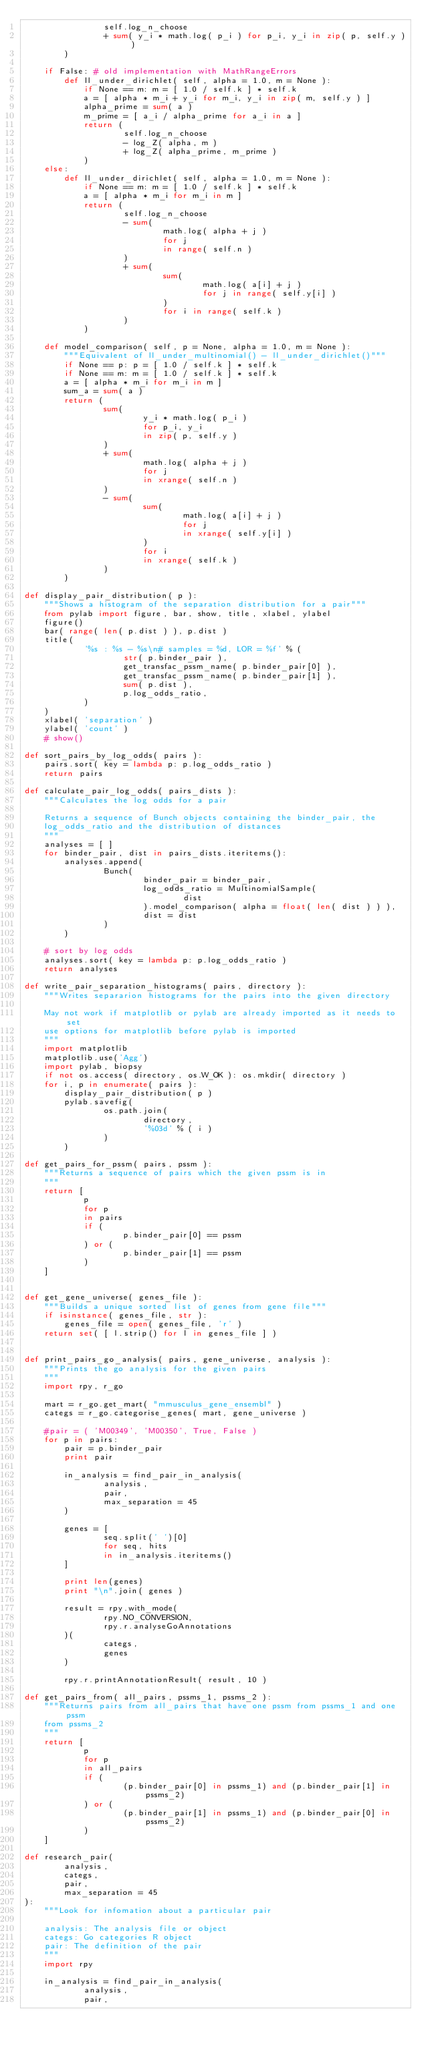Convert code to text. <code><loc_0><loc_0><loc_500><loc_500><_Python_>                self.log_n_choose
                + sum( y_i * math.log( p_i ) for p_i, y_i in zip( p, self.y ) )
        )

    if False: # old implementation with MathRangeErrors
        def ll_under_dirichlet( self, alpha = 1.0, m = None ):
            if None == m: m = [ 1.0 / self.k ] * self.k
            a = [ alpha * m_i + y_i for m_i, y_i in zip( m, self.y ) ]
            alpha_prime = sum( a )
            m_prime = [ a_i / alpha_prime for a_i in a ]
            return (
                    self.log_n_choose
                    - log_Z( alpha, m )
                    + log_Z( alpha_prime, m_prime )
            )
    else:
        def ll_under_dirichlet( self, alpha = 1.0, m = None ):
            if None == m: m = [ 1.0 / self.k ] * self.k
            a = [ alpha * m_i for m_i in m ]
            return (
                    self.log_n_choose
                    - sum(
                            math.log( alpha + j )
                            for j
                            in range( self.n )
                    )
                    + sum(
                            sum(
                                    math.log( a[i] + j )
                                    for j in range( self.y[i] )
                            )
                            for i in range( self.k )
                    )
            )

    def model_comparison( self, p = None, alpha = 1.0, m = None ):
        """Equivalent of ll_under_multinomial() - ll_under_dirichlet()"""
        if None == p: p = [ 1.0 / self.k ] * self.k
        if None == m: m = [ 1.0 / self.k ] * self.k
        a = [ alpha * m_i for m_i in m ]
        sum_a = sum( a )
        return (
                sum(
                        y_i * math.log( p_i )
                        for p_i, y_i
                        in zip( p, self.y )
                )
                + sum(
                        math.log( alpha + j )
                        for j
                        in xrange( self.n )
                )
                - sum(
                        sum(
                                math.log( a[i] + j )
                                for j
                                in xrange( self.y[i] )
                        )
                        for i
                        in xrange( self.k )
                )
        )

def display_pair_distribution( p ):
    """Shows a histogram of the separation distribution for a pair"""
    from pylab import figure, bar, show, title, xlabel, ylabel
    figure()
    bar( range( len( p.dist ) ), p.dist )
    title(
            '%s : %s - %s\n# samples = %d, LOR = %f' % (
                    str( p.binder_pair ),
                    get_transfac_pssm_name( p.binder_pair[0] ),
                    get_transfac_pssm_name( p.binder_pair[1] ),
                    sum( p.dist ),
                    p.log_odds_ratio,
            )
    )
    xlabel( 'separation' )
    ylabel( 'count' )
    # show()

def sort_pairs_by_log_odds( pairs ):
    pairs.sort( key = lambda p: p.log_odds_ratio )
    return pairs

def calculate_pair_log_odds( pairs_dists ):
    """Calculates the log odds for a pair

    Returns a sequence of Bunch objects containing the binder_pair, the
    log_odds_ratio and the distribution of distances
    """
    analyses = [ ]
    for binder_pair, dist in pairs_dists.iteritems():
        analyses.append(
                Bunch(
                        binder_pair = binder_pair,
                        log_odds_ratio = MultinomialSample(
                                dist
                        ).model_comparison( alpha = float( len( dist ) ) ),
                        dist = dist
                )
        )

    # sort by log odds
    analyses.sort( key = lambda p: p.log_odds_ratio )
    return analyses

def write_pair_separation_histograms( pairs, directory ):
    """Writes separarion histograms for the pairs into the given directory

    May not work if matplotlib or pylab are already imported as it needs to set
    use options for matplotlib before pylab is imported
    """
    import matplotlib
    matplotlib.use('Agg')
    import pylab, biopsy
    if not os.access( directory, os.W_OK ): os.mkdir( directory )
    for i, p in enumerate( pairs ):
        display_pair_distribution( p )
        pylab.savefig(
                os.path.join(
                        directory,
                        '%03d' % ( i )
                )
        )

def get_pairs_for_pssm( pairs, pssm ):
    """Returns a sequence of pairs which the given pssm is in
    """
    return [
            p
            for p
            in pairs
            if (
                    p.binder_pair[0] == pssm
            ) or (
                    p.binder_pair[1] == pssm
            )
    ]


def get_gene_universe( genes_file ):
    """Builds a unique sorted list of genes from gene file"""
    if isinstance( genes_file, str ):
        genes_file = open( genes_file, 'r' )
    return set( [ l.strip() for l in genes_file ] )


def print_pairs_go_analysis( pairs, gene_universe, analysis ):
    """Prints the go analysis for the given pairs
    """
    import rpy, r_go

    mart = r_go.get_mart( "mmusculus_gene_ensembl" )
    categs = r_go.categorise_genes( mart, gene_universe )

    #pair = ( 'M00349', 'M00350', True, False )
    for p in pairs:
        pair = p.binder_pair
        print pair

        in_analysis = find_pair_in_analysis(
                analysis,
                pair,
                max_separation = 45
        )

        genes = [
                seq.split(' ')[0]
                for seq, hits
                in in_analysis.iteritems()
        ]

        print len(genes)
        print "\n".join( genes )

        result = rpy.with_mode(
                rpy.NO_CONVERSION,
                rpy.r.analyseGoAnnotations
        )(
                categs,
                genes
        )

        rpy.r.printAnnotationResult( result, 10 )

def get_pairs_from( all_pairs, pssms_1, pssms_2 ):
    """Returns pairs from all_pairs that have one pssm from pssms_1 and one pssm
    from pssms_2
    """
    return [
            p
            for p
            in all_pairs
            if (
                    (p.binder_pair[0] in pssms_1) and (p.binder_pair[1] in pssms_2)
            ) or (
                    (p.binder_pair[1] in pssms_1) and (p.binder_pair[0] in pssms_2)
            )
    ]

def research_pair(
        analysis,
        categs,
        pair,
        max_separation = 45
):
    """Look for infomation about a particular pair

    analysis: The analysis file or object
    categs: Go categories R object
    pair: The definition of the pair
    """
    import rpy

    in_analysis = find_pair_in_analysis(
            analysis,
            pair,</code> 